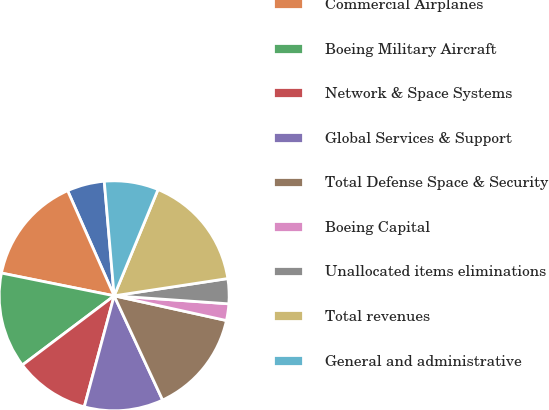<chart> <loc_0><loc_0><loc_500><loc_500><pie_chart><fcel>(Dollars in millions except<fcel>Commercial Airplanes<fcel>Boeing Military Aircraft<fcel>Network & Space Systems<fcel>Global Services & Support<fcel>Total Defense Space & Security<fcel>Boeing Capital<fcel>Unallocated items eliminations<fcel>Total revenues<fcel>General and administrative<nl><fcel>5.26%<fcel>15.2%<fcel>13.45%<fcel>10.53%<fcel>11.11%<fcel>14.62%<fcel>2.34%<fcel>3.51%<fcel>16.37%<fcel>7.6%<nl></chart> 